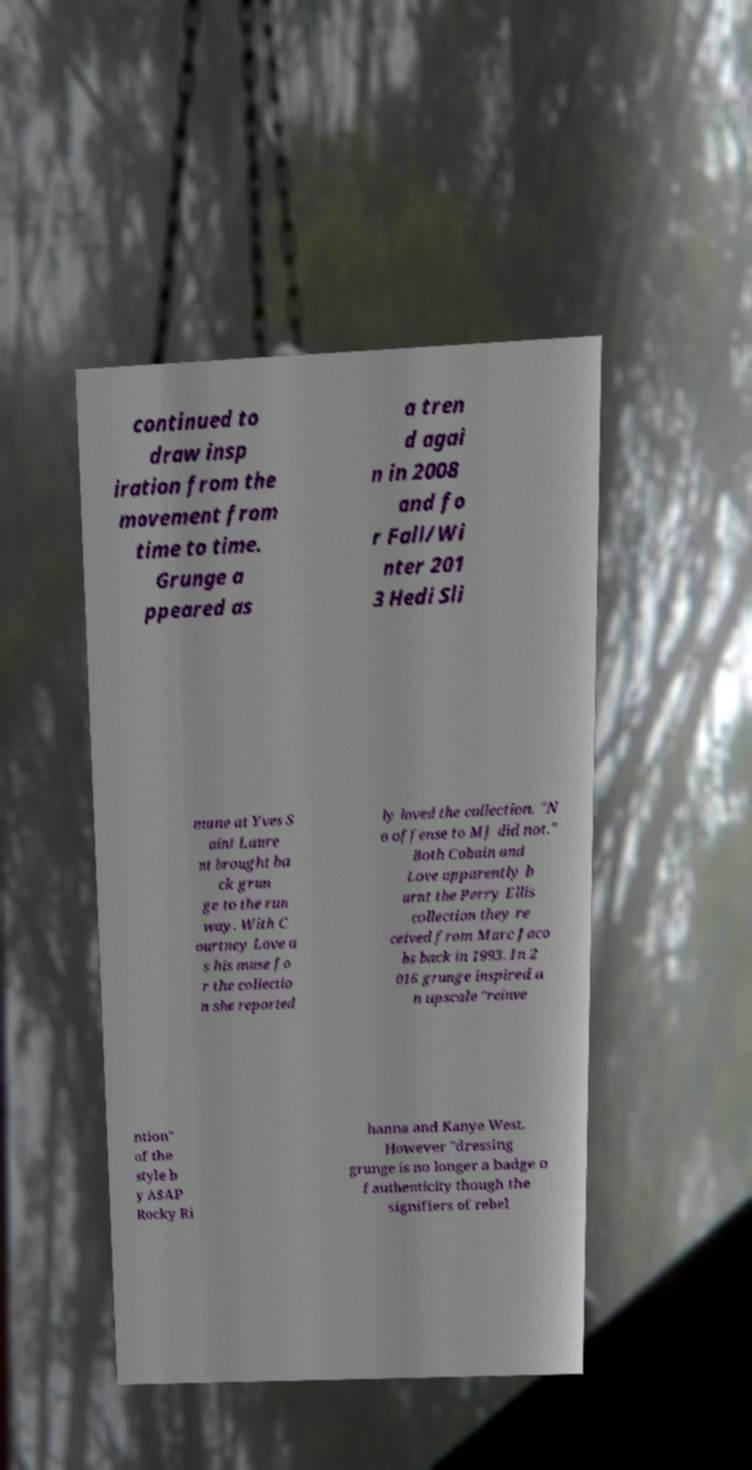Please identify and transcribe the text found in this image. continued to draw insp iration from the movement from time to time. Grunge a ppeared as a tren d agai n in 2008 and fo r Fall/Wi nter 201 3 Hedi Sli mane at Yves S aint Laure nt brought ba ck grun ge to the run way. With C ourtney Love a s his muse fo r the collectio n she reported ly loved the collection. "N o offense to MJ did not." Both Cobain and Love apparently b urnt the Perry Ellis collection they re ceived from Marc Jaco bs back in 1993. In 2 016 grunge inspired a n upscale "reinve ntion" of the style b y A$AP Rocky Ri hanna and Kanye West. However "dressing grunge is no longer a badge o f authenticity though the signifiers of rebel 